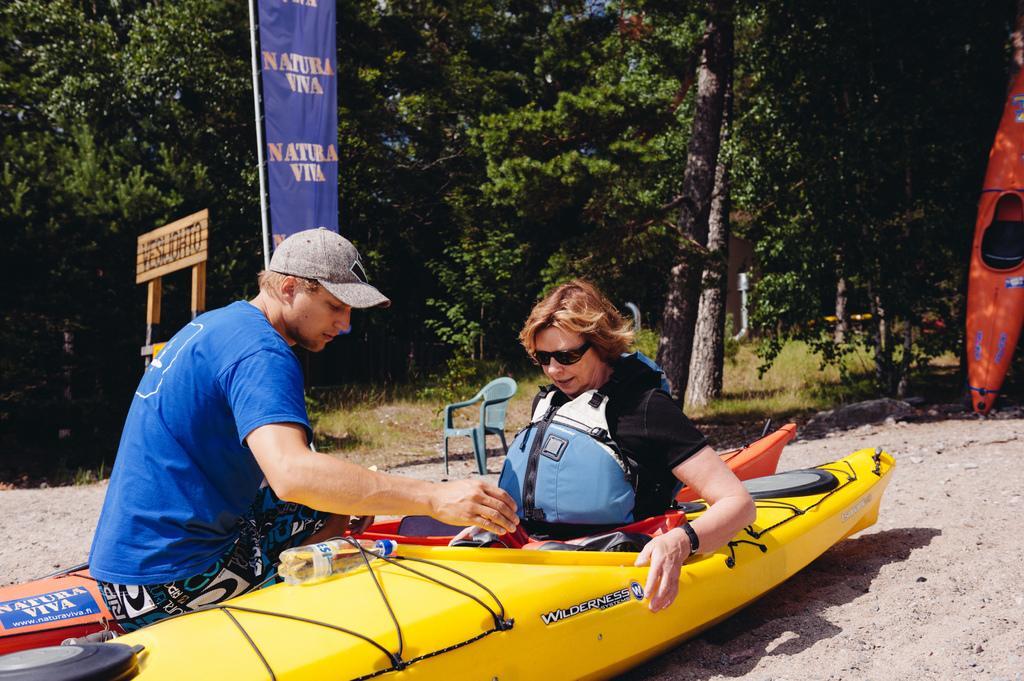Describe this image in one or two sentences. In this image, we can see two person wearing clothes. There is a boat and bottle at the bottom of the image. There is a chair in the middle of the image. There is a banner flag and board on the left side of the image. There is an another board on the right side of the image. In the background, we can see some trees. 